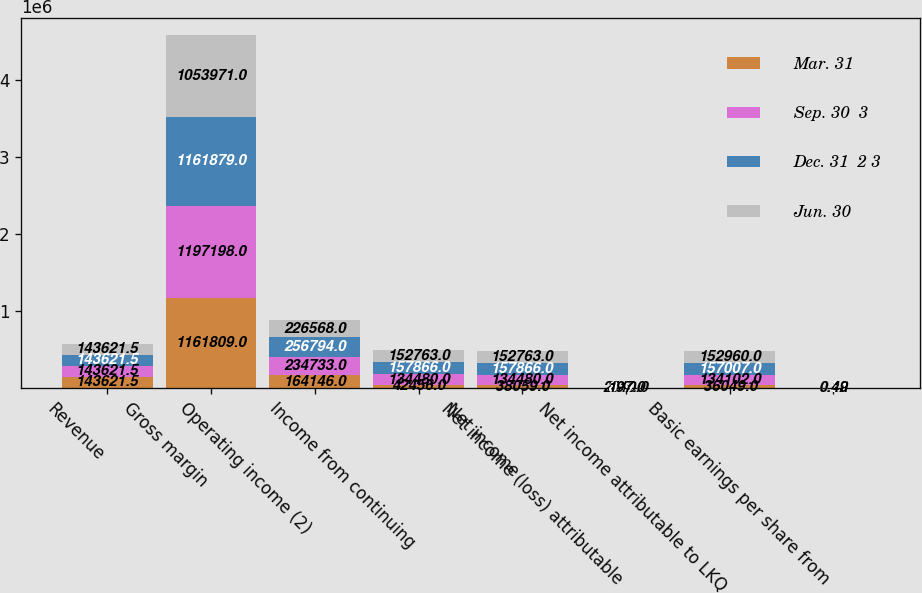Convert chart to OTSL. <chart><loc_0><loc_0><loc_500><loc_500><stacked_bar_chart><ecel><fcel>Revenue<fcel>Gross margin<fcel>Operating income (2)<fcel>Income from continuing<fcel>Net income<fcel>Net income (loss) attributable<fcel>Net income attributable to LKQ<fcel>Basic earnings per share from<nl><fcel>Mar. 31<fcel>143622<fcel>1.16181e+06<fcel>164146<fcel>42456<fcel>38059<fcel>2010<fcel>36049<fcel>0.13<nl><fcel>Sep. 30  3<fcel>143622<fcel>1.1972e+06<fcel>234733<fcel>134480<fcel>134480<fcel>378<fcel>134102<fcel>0.42<nl><fcel>Dec. 31  2 3<fcel>143622<fcel>1.16188e+06<fcel>256794<fcel>157866<fcel>157866<fcel>859<fcel>157007<fcel>0.51<nl><fcel>Jun. 30<fcel>143622<fcel>1.05397e+06<fcel>226568<fcel>152763<fcel>152763<fcel>197<fcel>152960<fcel>0.49<nl></chart> 